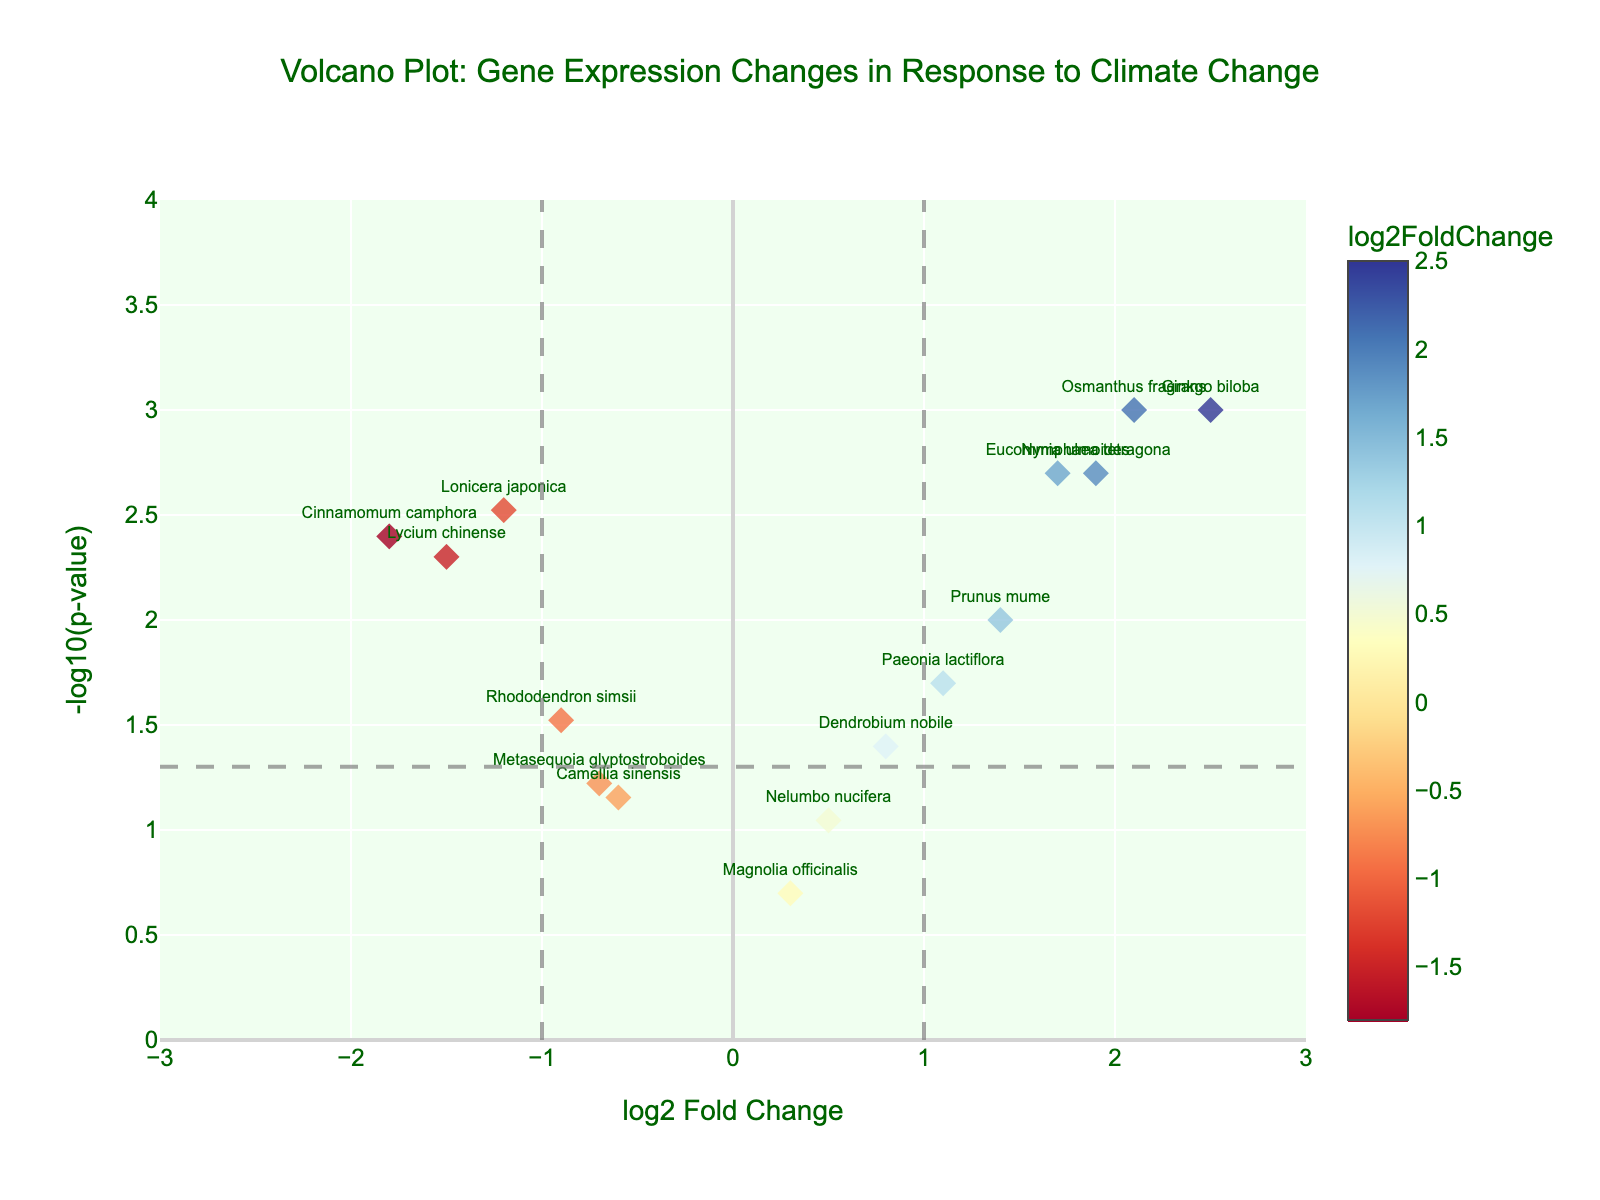What's the title of the plot? The title of the plot is prominently displayed at the top center of the figure. It reads "Volcano Plot: Gene Expression Changes in Response to Climate Change".
Answer: Volcano Plot: Gene Expression Changes in Response to Climate Change What are the x and y axes representing? The x-axis represents the log2 Fold Change, which indicates the change in gene expression levels, and the y-axis represents -log10(p-value), which indicates the statistical significance of the changes.
Answer: log2 Fold Change and -log10(p-value) How many genes have a p-value less than 0.05? Genes with p-values less than 0.05 are represented as having y-values greater than 1.301 (-log10(0.05)). Count the number of points above this horizontal threshold. There are Lonicera japonica, Ginkgo biloba, Eucommia ulmoides, Lycium chinense, Osmanthus fragrans, Cinnamomum camphora, Paeonia lactiflora, Rhododendron simsii, Prunus mume, and Nymphaea tetragona. So, there are 10 points above the threshold.
Answer: 10 Which gene shows the highest up-regulation in response to climate change? Up-regulation is indicated by the highest positive log2 Fold Change value. Among the data points, Osmanthus fragrans has the highest log2 Fold Change of 2.1.
Answer: Osmanthus fragrans Which gene shows the most significant down-regulation? Down-regulation is indicated by negative log2 Fold Change values. The most significant down-regulation is the gene with the lowest log2 Fold Change. Cinnamomum camphora has the lowest log2 Fold Change of -1.8.
Answer: Cinnamomum camphora How many genes are neither significantly up-regulated nor down-regulated according to the thresholds (log2 Fold Change between -1 and 1 and p-value > 0.05)? Look for genes that fall within -1 and 1 for log2 Fold Change and have a y-value less than 1.301 (-log10(0.05)). These are Dendrobium nobile, Camellia sinensis, Magnolia officinalis, Nelumbo nucifera, and Metasequoia glyptostroboides. There are 5 such genes.
Answer: 5 What color scale is used to differentiate the log2 Fold Change values? The color scale moves from blue (lower fold change) to red (higher fold change), as denoted by the color bar on the plot.
Answer: RdYlBu Which gene is closest to the intersection of thresholds (log2 Fold Change of 1 or -1 and p-value of 0.05)? To find the intersection thresholds, look at genes closest to (-1 or 1, and 1.301). Prunus mume at (1.4, 2.0) is closest to the intersection near 1 and 1.301. Lycium chinense is closest at (-1.5, 2.3) on the negative side.
Answer: Prunus mume or Lycium chinense How does the plot highlight significant changes in gene expression? Significant changes are highlighted by markers that lie outside the vertical dashed lines at log2 Fold Change of -1 and 1, and above the horizontal dashed line at -log10(p-value) of 1.301 (p = 0.05).
Answer: Dashed lines and marker placement 